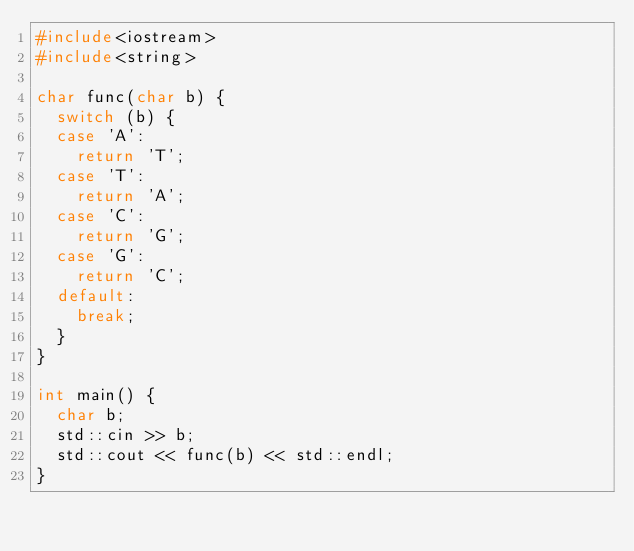<code> <loc_0><loc_0><loc_500><loc_500><_C++_>#include<iostream>
#include<string>

char func(char b) {
	switch (b) {
	case 'A':
		return 'T';
	case 'T':
		return 'A';
	case 'C':
		return 'G';
	case 'G':
		return 'C';
	default:
		break;
	}
}

int main() {
	char b;
	std::cin >> b;
	std::cout << func(b) << std::endl;
}</code> 